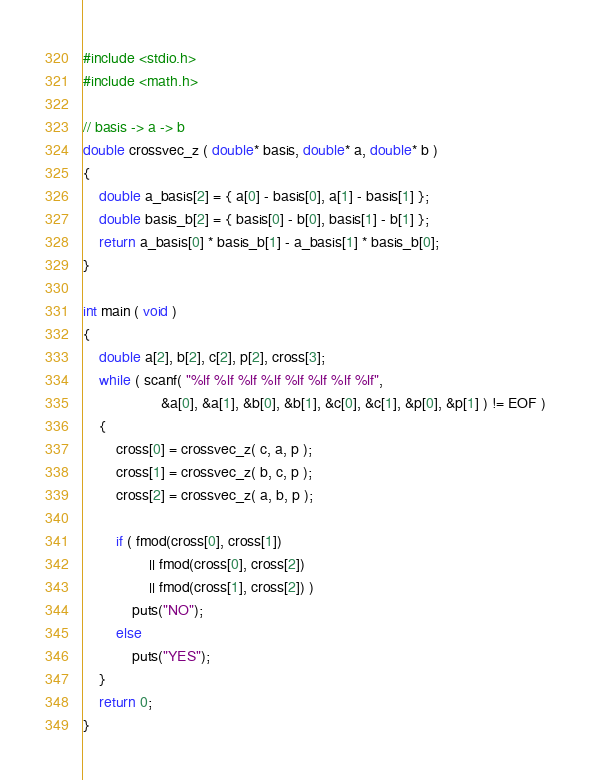<code> <loc_0><loc_0><loc_500><loc_500><_C_>#include <stdio.h>
#include <math.h>

// basis -> a -> b
double crossvec_z ( double* basis, double* a, double* b )
{
    double a_basis[2] = { a[0] - basis[0], a[1] - basis[1] };
    double basis_b[2] = { basis[0] - b[0], basis[1] - b[1] };
    return a_basis[0] * basis_b[1] - a_basis[1] * basis_b[0];
}

int main ( void )
{
    double a[2], b[2], c[2], p[2], cross[3];
    while ( scanf( "%lf %lf %lf %lf %lf %lf %lf %lf",
                   &a[0], &a[1], &b[0], &b[1], &c[0], &c[1], &p[0], &p[1] ) != EOF )
    {
        cross[0] = crossvec_z( c, a, p );
        cross[1] = crossvec_z( b, c, p );
        cross[2] = crossvec_z( a, b, p );

        if ( fmod(cross[0], cross[1])
                || fmod(cross[0], cross[2])
                || fmod(cross[1], cross[2]) )
            puts("NO");
        else
            puts("YES");
    }
    return 0;
}</code> 